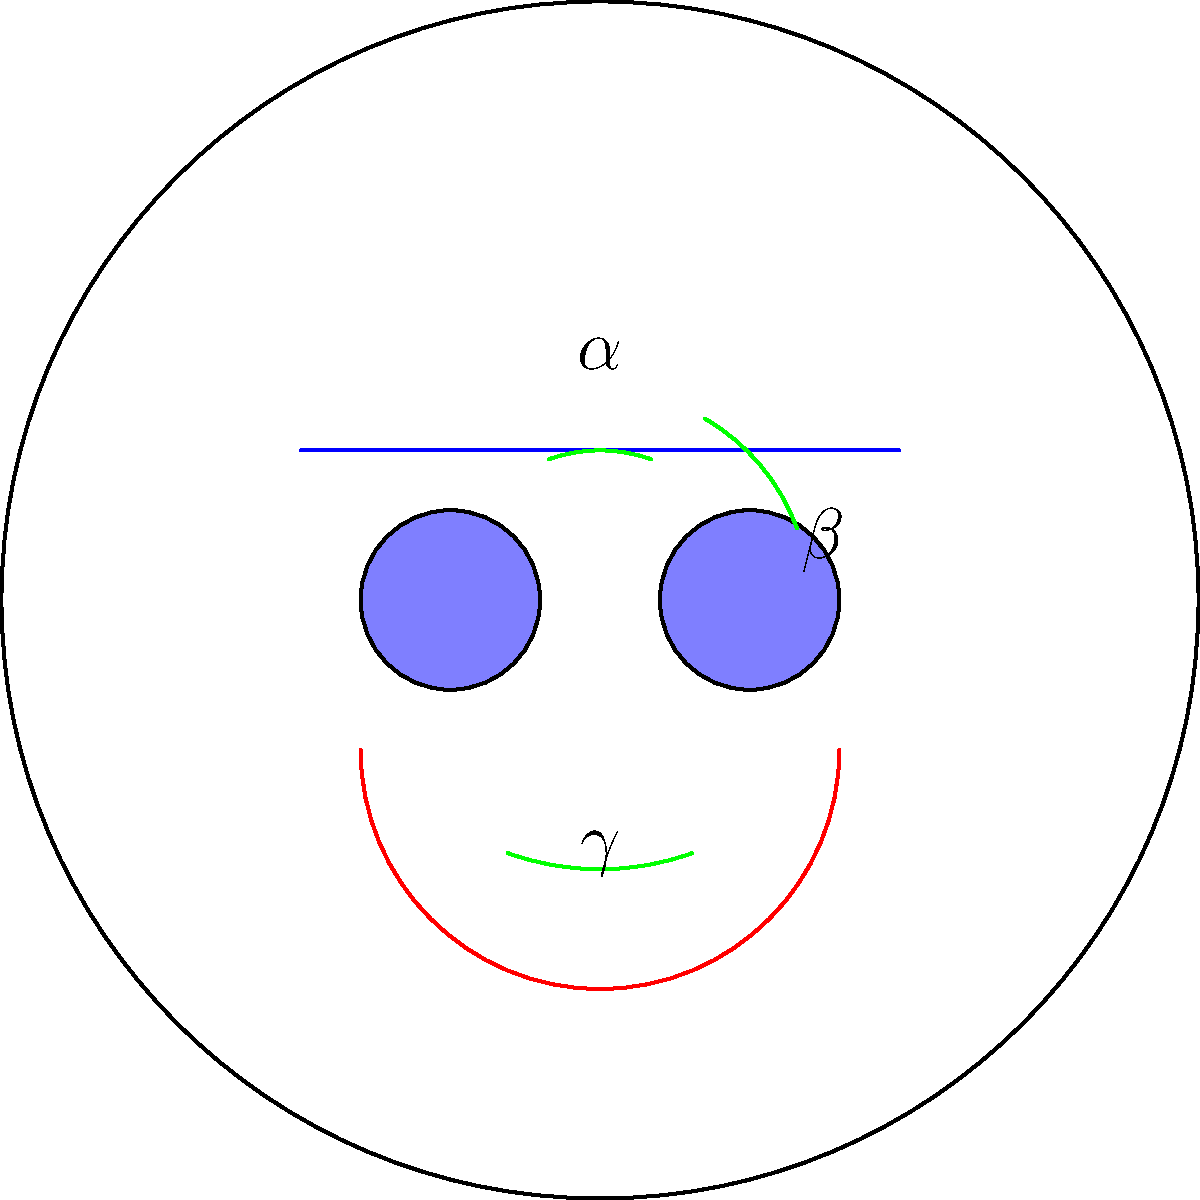In analyzing the facial expressions of cartoon characters and their potential impact on child viewers, you're studying the angles formed by key facial features. In the given cartoon face, three angles are marked: $\alpha$ (eyebrow angle), $\beta$ (eye angle), and $\gamma$ (smile angle). If $\alpha = 40^\circ$ and $\beta = 40^\circ$, what is the measure of $\gamma$, assuming these three angles form a straight line when connected at the center of the face? To solve this problem, let's follow these steps:

1) First, recall that angles on a straight line sum to 180°. This is because a straight line forms a 180° angle.

2) We are given that the three angles $\alpha$, $\beta$, and $\gamma$ form a straight line when connected at the center of the face. Therefore:

   $\alpha + \beta + \gamma = 180^\circ$

3) We are also given the values of $\alpha$ and $\beta$:
   $\alpha = 40^\circ$
   $\beta = 40^\circ$

4) Let's substitute these values into our equation:

   $40^\circ + 40^\circ + \gamma = 180^\circ$

5) Simplify:
   $80^\circ + \gamma = 180^\circ$

6) To solve for $\gamma$, subtract 80° from both sides:

   $\gamma = 180^\circ - 80^\circ = 100^\circ$

Therefore, the measure of angle $\gamma$ (the smile angle) is 100°.
Answer: $100^\circ$ 